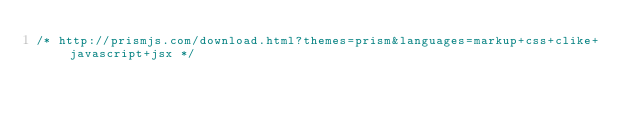<code> <loc_0><loc_0><loc_500><loc_500><_JavaScript_>/* http://prismjs.com/download.html?themes=prism&languages=markup+css+clike+javascript+jsx */</code> 